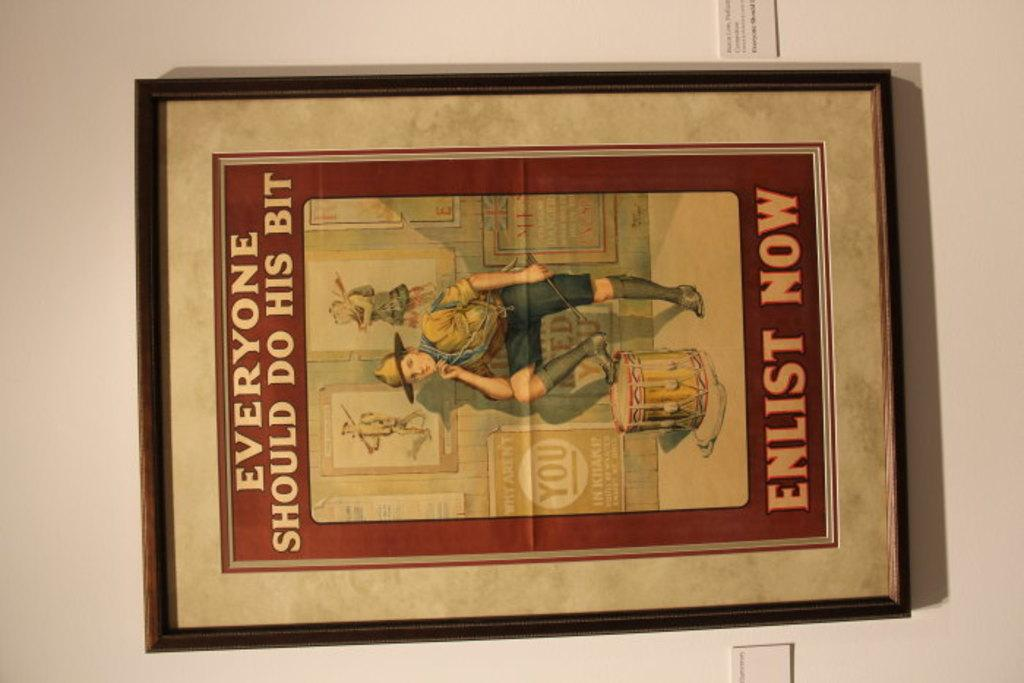<image>
Write a terse but informative summary of the picture. Picture that says Everyone Should Do His Bit of a ban putting his leg on a drum. 